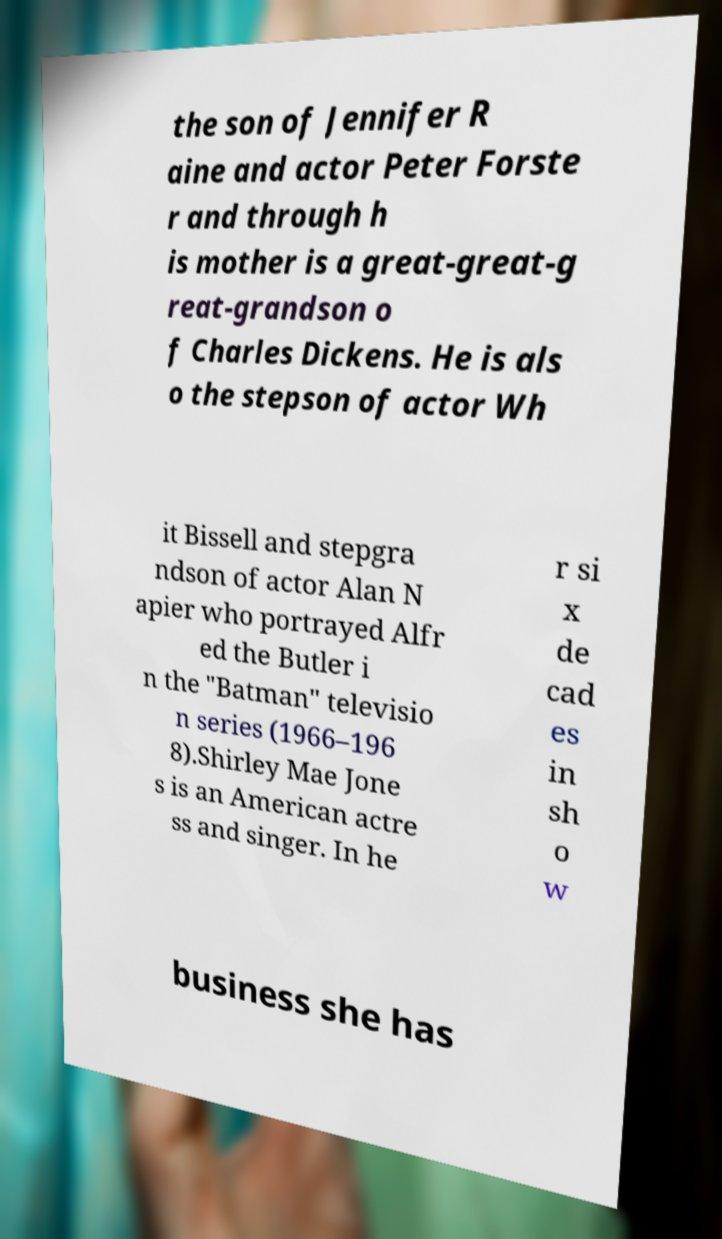For documentation purposes, I need the text within this image transcribed. Could you provide that? the son of Jennifer R aine and actor Peter Forste r and through h is mother is a great-great-g reat-grandson o f Charles Dickens. He is als o the stepson of actor Wh it Bissell and stepgra ndson of actor Alan N apier who portrayed Alfr ed the Butler i n the "Batman" televisio n series (1966–196 8).Shirley Mae Jone s is an American actre ss and singer. In he r si x de cad es in sh o w business she has 